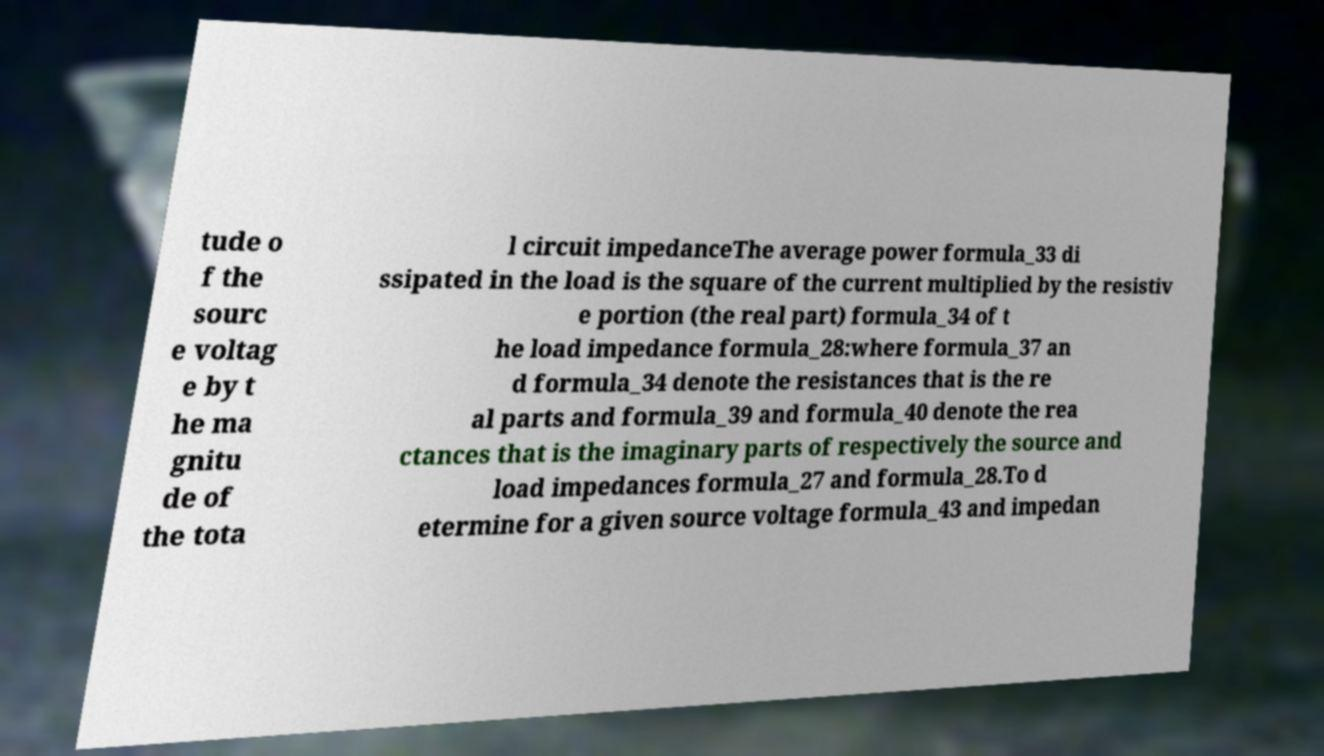Could you extract and type out the text from this image? tude o f the sourc e voltag e by t he ma gnitu de of the tota l circuit impedanceThe average power formula_33 di ssipated in the load is the square of the current multiplied by the resistiv e portion (the real part) formula_34 of t he load impedance formula_28:where formula_37 an d formula_34 denote the resistances that is the re al parts and formula_39 and formula_40 denote the rea ctances that is the imaginary parts of respectively the source and load impedances formula_27 and formula_28.To d etermine for a given source voltage formula_43 and impedan 